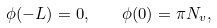Convert formula to latex. <formula><loc_0><loc_0><loc_500><loc_500>\phi ( - L ) = 0 , \quad \phi ( 0 ) = \pi N _ { v } ,</formula> 